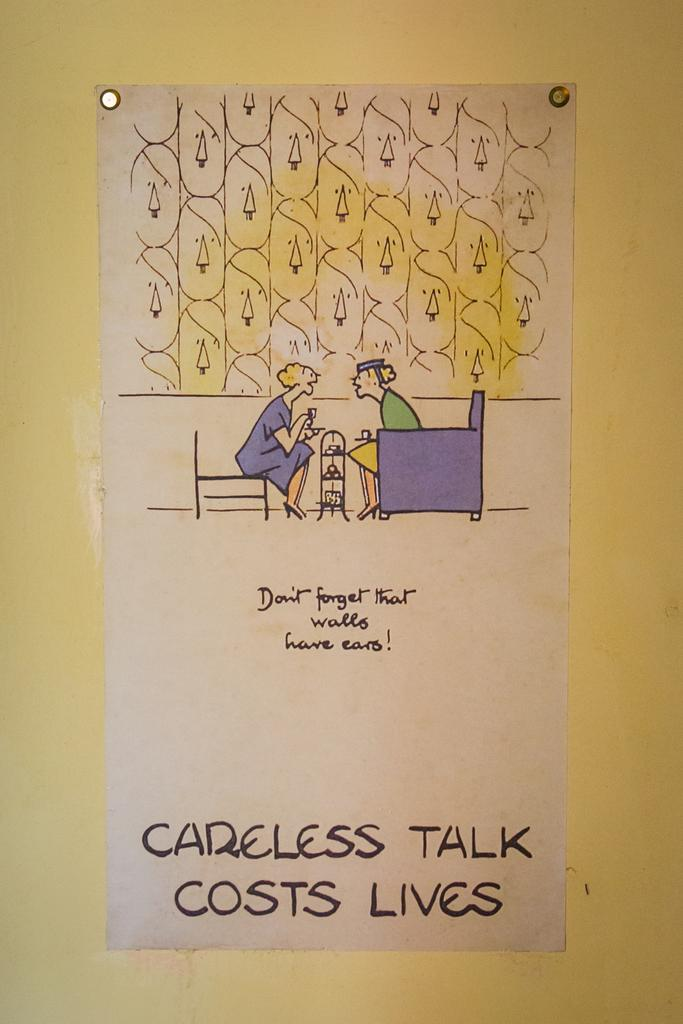What is on the wall in the image? There is a poster on the wall in the image. What can be seen in the poster? The poster contains a depiction of persons. Are there any words on the poster? Yes, the poster contains some text. What type of seed is being planted in the image? There is no seed or planting activity depicted in the image; it features a poster with a depiction of persons and some text. 